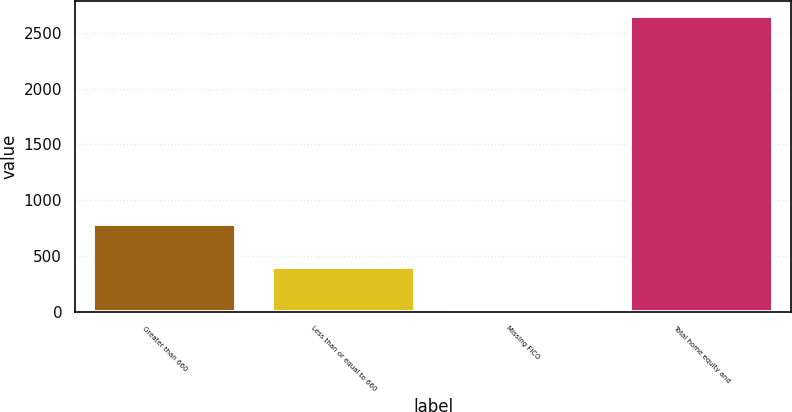<chart> <loc_0><loc_0><loc_500><loc_500><bar_chart><fcel>Greater than 660<fcel>Less than or equal to 660<fcel>Missing FICO<fcel>Total home equity and<nl><fcel>791<fcel>405<fcel>8<fcel>2649<nl></chart> 